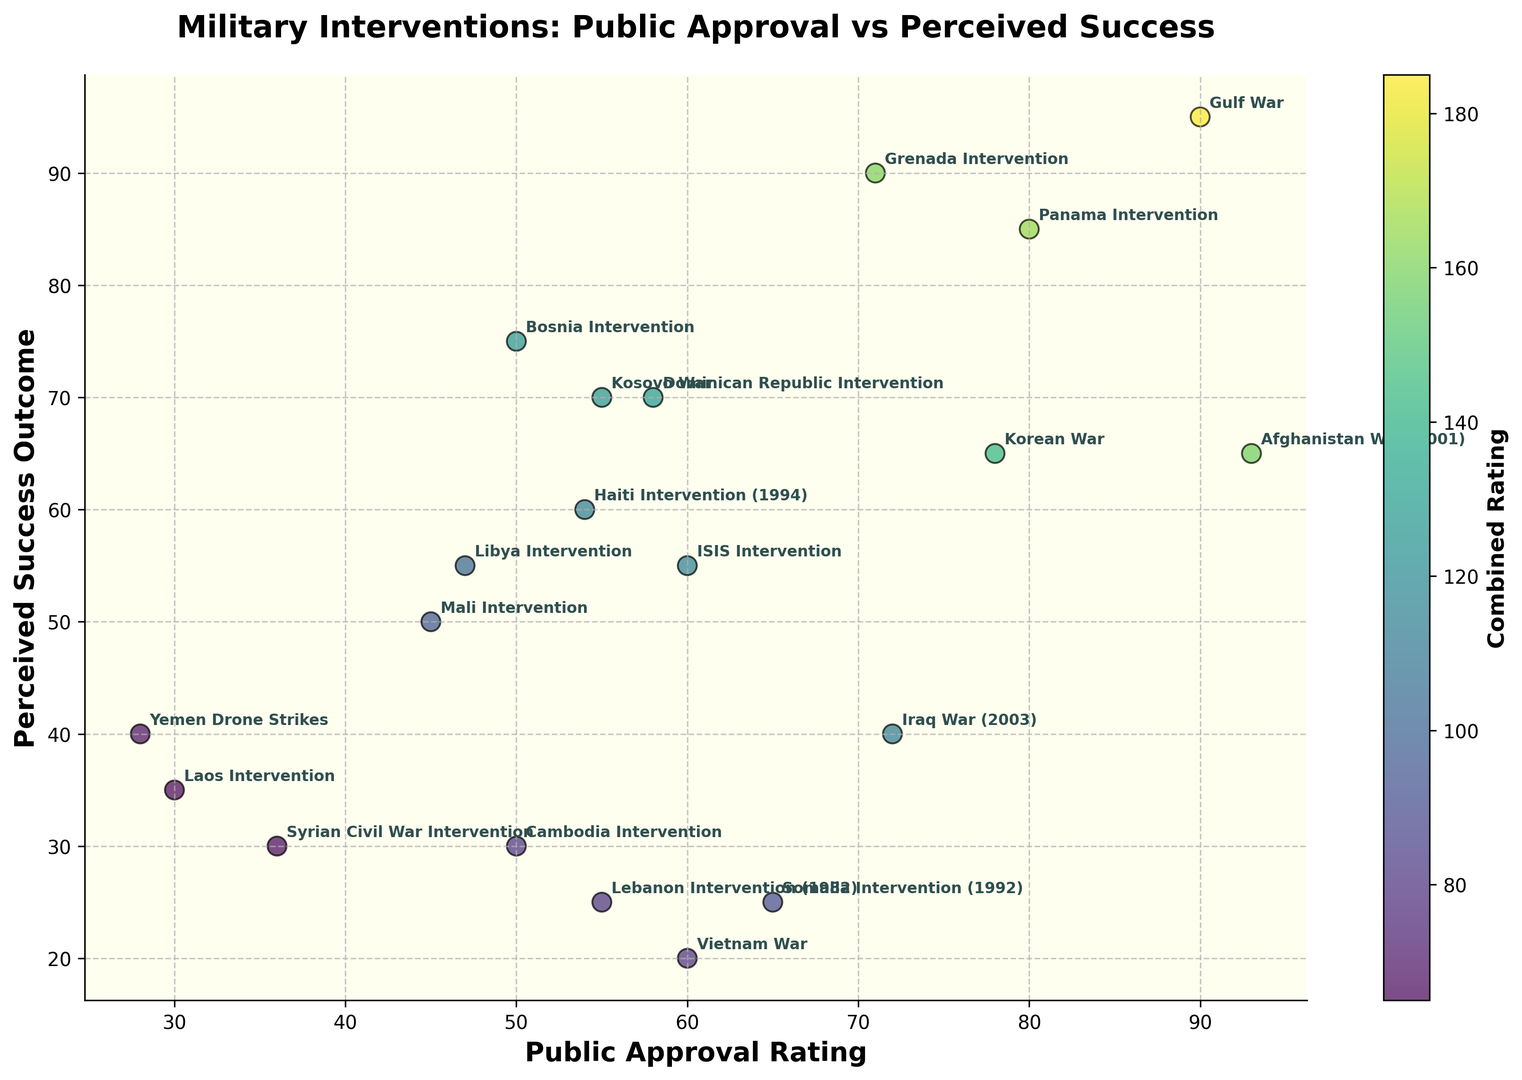Which military intervention had the highest public approval rating? The highest point on the x-axis represents the Gulf War with a public approval rating of 90.
Answer: Gulf War Which military intervention had the lowest perceived success outcome? The lowest point on the y-axis represents the Somalia Intervention with a perceived success outcome of 25.
Answer: Somalia Intervention (1992) What is the combined rating for the Grenada Intervention? The Grenada Intervention is located at 71 on the x-axis and 90 on the y-axis. The combined rating is 71 + 90.
Answer: 161 Do most military interventions with high public approval ratings (above 80) also have high perceived success outcomes (above 80)? Interventions above 80 in public approval rating include Gulf War, Panama Intervention, and Afghanistan War. Among these, only the Gulf War and Panama Intervention have perceived success outcomes above 80.
Answer: No Which intervention has a higher perceived success outcome, the Libya Intervention or the Kosovo War? The Kosovo War is located higher on the y-axis at 70, compared to the Libya Intervention at 55 on the y-axis.
Answer: Kosovo War Which intervention had the lowest public approval rating and what was its perceived success outcome? The Yemen Drone Strikes has the lowest point on the x-axis with a public approval rating of 28 and a perceived success outcome of 40.
Answer: Yemen Drone Strikes, 40 Is there an intervention where the perceived success outcome is significantly higher than its public approval rating? The Bosnia Intervention has a perceived success outcome of 75, significantly higher compared to its public approval rating of 50.
Answer: Bosnia Intervention Comparing the Vietnam War and the Korean War, which had a higher public approval rating and which had a higher perceived success outcome? Vietnam War has a public approval rating of 60 and a perceived success outcome of 20; Korean War has a public approval rating of 78 and a perceived success outcome of 65. Both ratings are higher for the Korean War.
Answer: Korean War What's the average public approval rating for the interventions in the middle range of perceived success outcomes (40–70)? Interventions in this range include Kosovo War, Libya Intervention, Afghanistan War, Korea War, Dominican Republic Intervention, Iraq War, Cambodia Intervention, ISIS Intervention, and Haiti Intervention. Their public approval ratings are (55 + 47 + 93 + 78 + 58 + 72 + 50 + 60 + 54)/9.
Answer: 63 If the color intensity represents the combined rating, which intervention appears the darkest? Based on color intensity, which represents the combined rating, the Grenada Intervention appears the darkest with a combined score of 161.
Answer: Grenada Intervention 